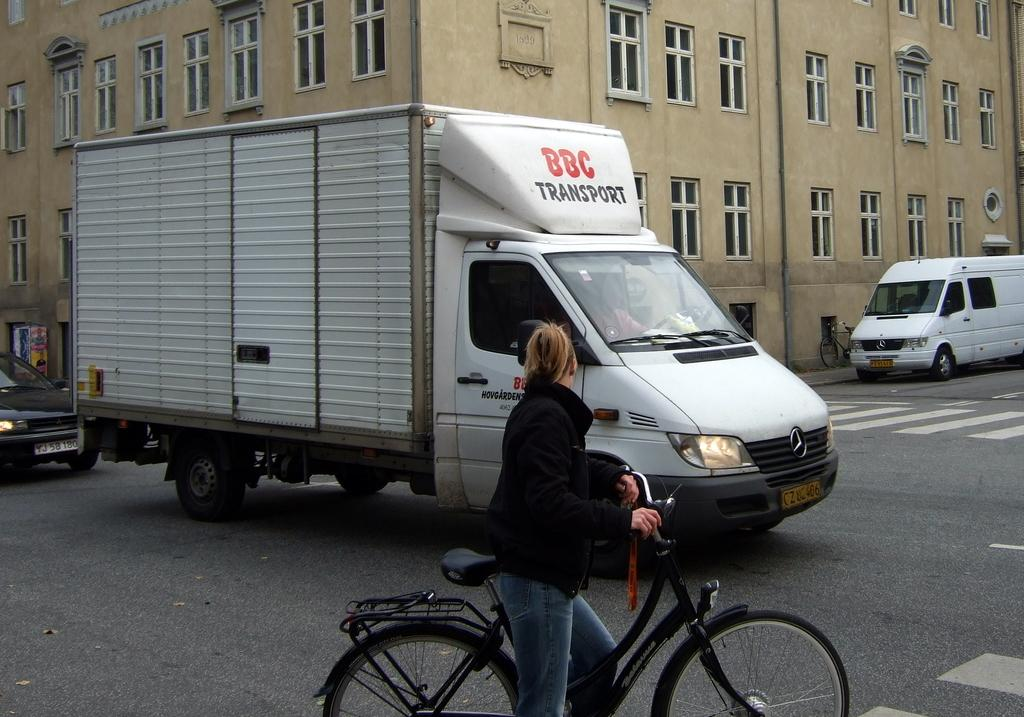<image>
Provide a brief description of the given image. A bicyclist waiting for a BBC transport van so she can cross the street. 